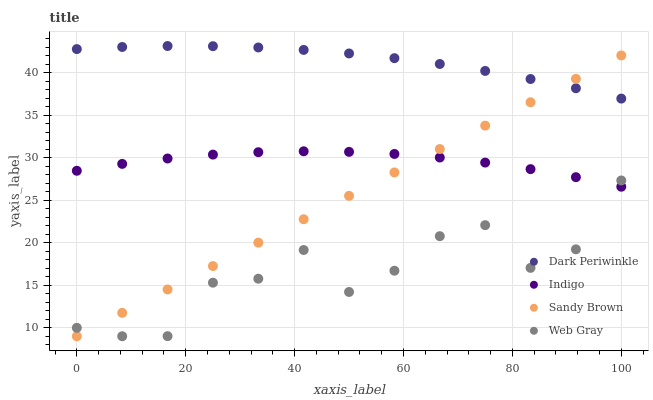Does Web Gray have the minimum area under the curve?
Answer yes or no. Yes. Does Dark Periwinkle have the maximum area under the curve?
Answer yes or no. Yes. Does Indigo have the minimum area under the curve?
Answer yes or no. No. Does Indigo have the maximum area under the curve?
Answer yes or no. No. Is Sandy Brown the smoothest?
Answer yes or no. Yes. Is Web Gray the roughest?
Answer yes or no. Yes. Is Indigo the smoothest?
Answer yes or no. No. Is Indigo the roughest?
Answer yes or no. No. Does Sandy Brown have the lowest value?
Answer yes or no. Yes. Does Indigo have the lowest value?
Answer yes or no. No. Does Dark Periwinkle have the highest value?
Answer yes or no. Yes. Does Indigo have the highest value?
Answer yes or no. No. Is Indigo less than Dark Periwinkle?
Answer yes or no. Yes. Is Dark Periwinkle greater than Indigo?
Answer yes or no. Yes. Does Indigo intersect Sandy Brown?
Answer yes or no. Yes. Is Indigo less than Sandy Brown?
Answer yes or no. No. Is Indigo greater than Sandy Brown?
Answer yes or no. No. Does Indigo intersect Dark Periwinkle?
Answer yes or no. No. 